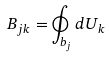Convert formula to latex. <formula><loc_0><loc_0><loc_500><loc_500>B _ { j k } = \oint _ { b _ { j } } d U _ { k }</formula> 